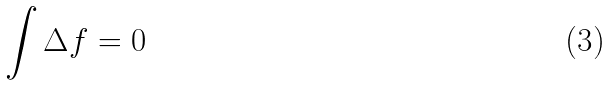<formula> <loc_0><loc_0><loc_500><loc_500>\int \Delta f = 0</formula> 